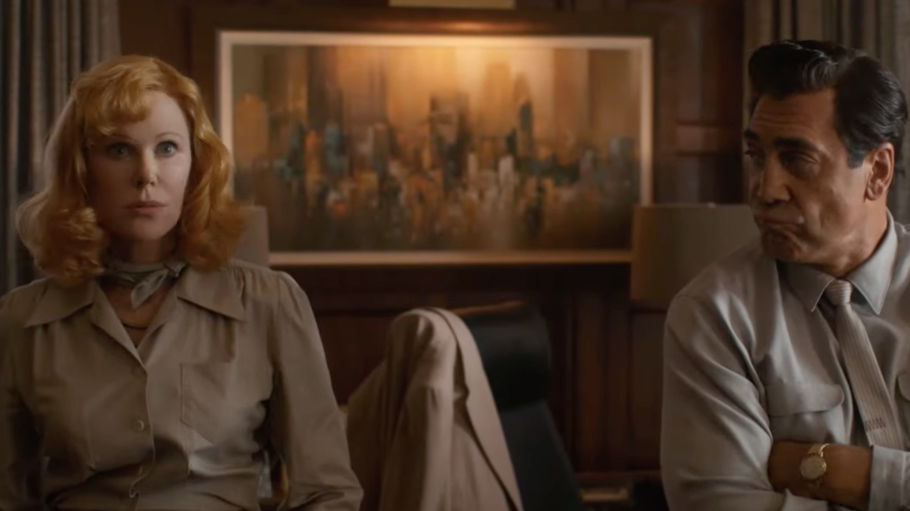What do you think is going on in this snapshot? This image captures a seemingly intense moment between two characters, portrayed by esteemed actors, in a wood-paneled office setting that suggests a narrative of power or corporate dynamics. The man, dressed sharply in a dark suit, seems contemplative or troubled, gazing away from his counterpart. The woman, clad in a classic beige trench coat, looks directly towards the viewer, her expression unreadable and poised, adding a layer of mystery. The large painting in the background could imply a setting of wealth or cultural importance, contributing to the film's atmosphere. 